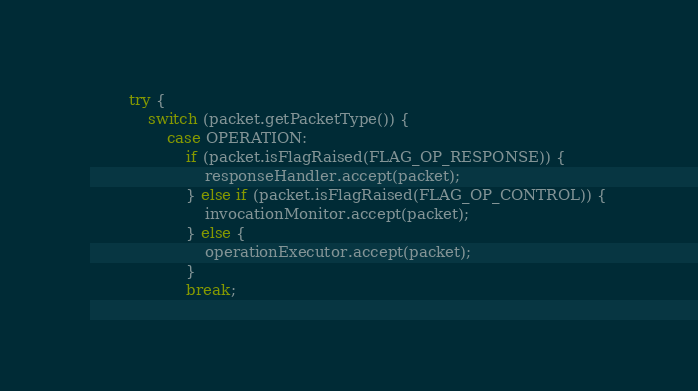<code> <loc_0><loc_0><loc_500><loc_500><_Java_>        try {
            switch (packet.getPacketType()) {
                case OPERATION:
                    if (packet.isFlagRaised(FLAG_OP_RESPONSE)) {
                        responseHandler.accept(packet);
                    } else if (packet.isFlagRaised(FLAG_OP_CONTROL)) {
                        invocationMonitor.accept(packet);
                    } else {
                        operationExecutor.accept(packet);
                    }
                    break;</code> 